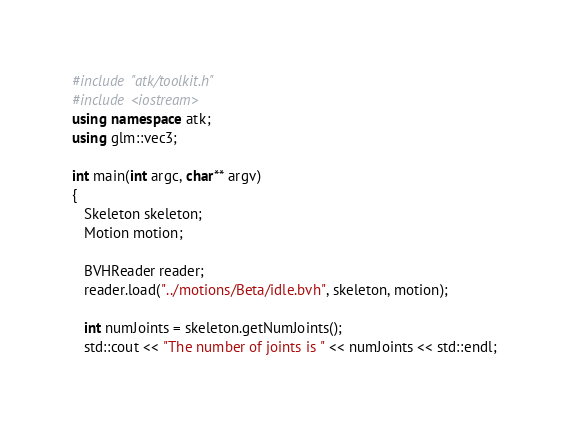Convert code to text. <code><loc_0><loc_0><loc_500><loc_500><_C++_>#include "atk/toolkit.h"
#include <iostream>
using namespace atk;
using glm::vec3;

int main(int argc, char** argv)
{
   Skeleton skeleton;
   Motion motion;

   BVHReader reader;
   reader.load("../motions/Beta/idle.bvh", skeleton, motion);

   int numJoints = skeleton.getNumJoints(); 
   std::cout << "The number of joints is " << numJoints << std::endl;
</code> 